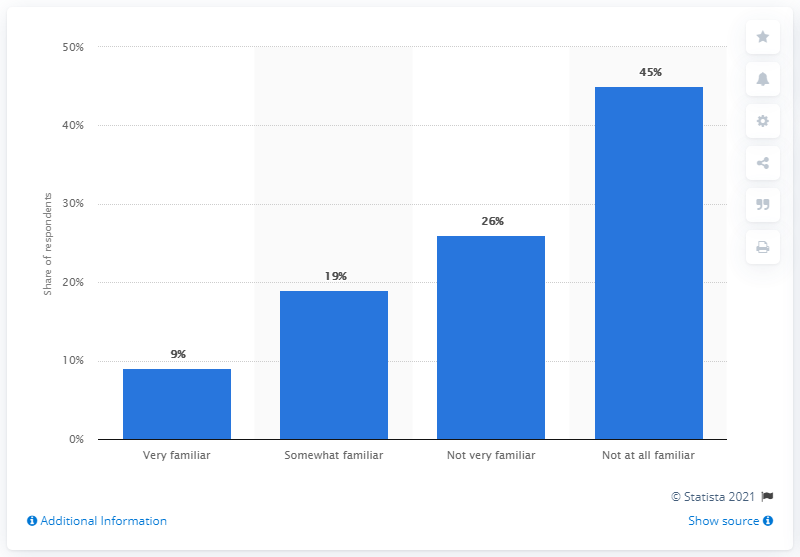List a handful of essential elements in this visual. In 2018, it was found that 28% of people in the US were at least somewhat familiar with HomeAway or VRBO. In 2018, approximately 45% of people were not at all familiar with HomeAway or VRBO. 